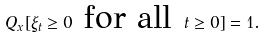<formula> <loc_0><loc_0><loc_500><loc_500>Q _ { x } [ \xi _ { t } \geq 0 \text { for all } t \geq 0 ] = 1 .</formula> 